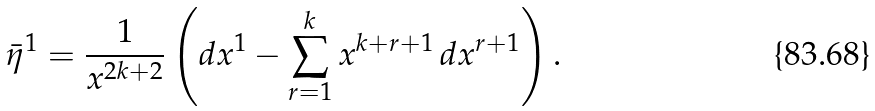<formula> <loc_0><loc_0><loc_500><loc_500>\bar { \eta } ^ { 1 } = \frac { 1 } { x ^ { 2 k + 2 } } \left ( d x ^ { 1 } - \sum _ { r = 1 } ^ { k } x ^ { k + r + 1 } \, d x ^ { r + 1 } \right ) .</formula> 